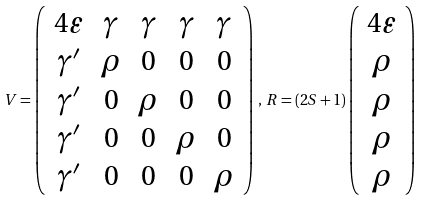Convert formula to latex. <formula><loc_0><loc_0><loc_500><loc_500>V = \left ( \begin{array} { c c c c c } 4 \varepsilon & \gamma & \gamma & \gamma & \gamma \\ \gamma ^ { \prime } & \rho & 0 & 0 & 0 \\ \gamma ^ { \prime } & 0 & \rho & 0 & 0 \\ \gamma ^ { \prime } & 0 & 0 & \rho & 0 \\ \gamma ^ { \prime } & 0 & 0 & 0 & \rho \end{array} \right ) \, , \, R = ( 2 S + 1 ) \left ( \begin{array} { c } 4 \varepsilon \\ \rho \\ \rho \\ \rho \\ \rho \end{array} \right )</formula> 